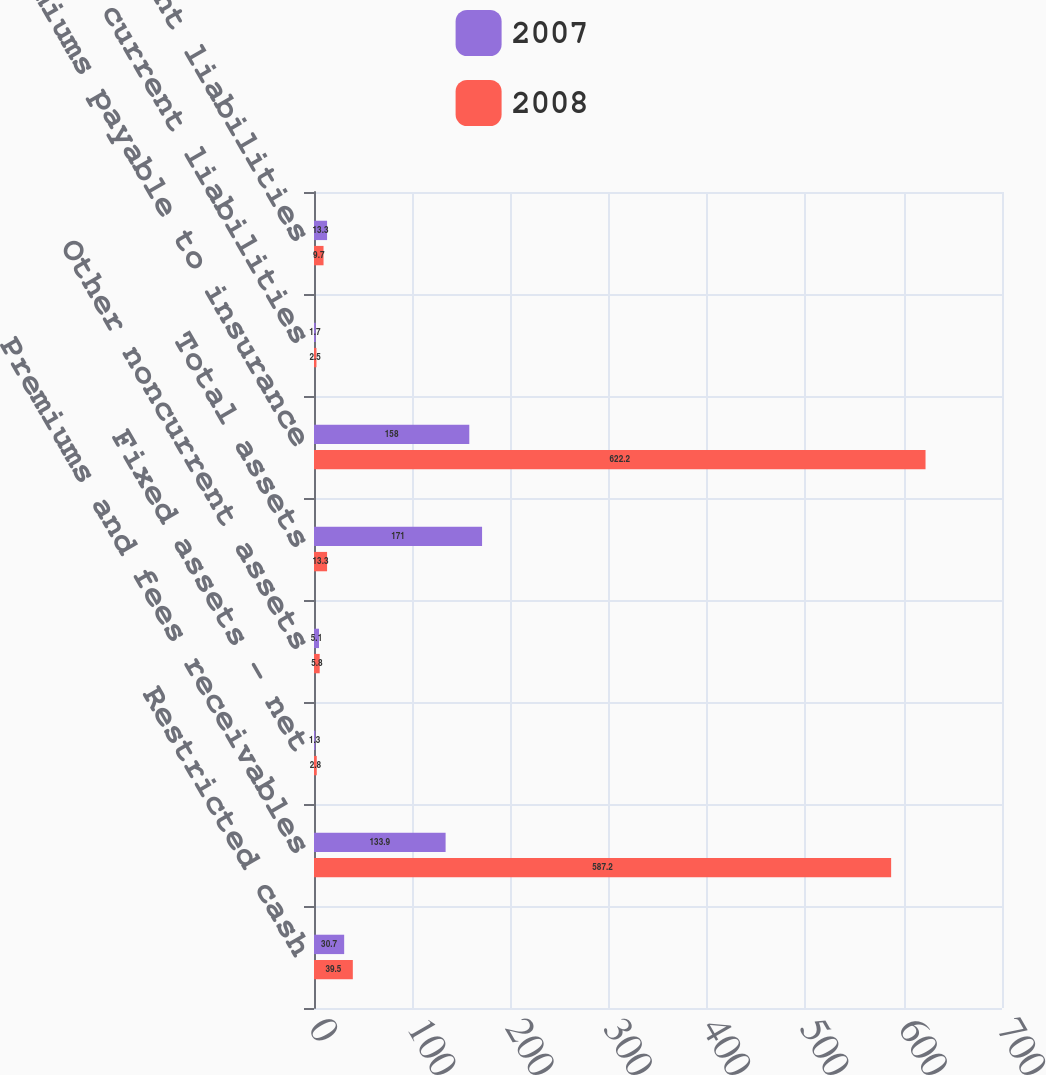Convert chart to OTSL. <chart><loc_0><loc_0><loc_500><loc_500><stacked_bar_chart><ecel><fcel>Restricted cash<fcel>Premiums and fees receivables<fcel>Fixed assets - net<fcel>Other noncurrent assets<fcel>Total assets<fcel>Premiums payable to insurance<fcel>Other current liabilities<fcel>Noncurrent liabilities<nl><fcel>2007<fcel>30.7<fcel>133.9<fcel>1.3<fcel>5.1<fcel>171<fcel>158<fcel>1.7<fcel>13.3<nl><fcel>2008<fcel>39.5<fcel>587.2<fcel>2.8<fcel>5.8<fcel>13.3<fcel>622.2<fcel>2.5<fcel>9.7<nl></chart> 